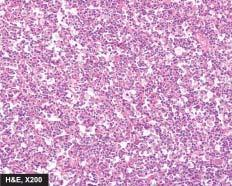what does the tumour show having high mitotic rate?
Answer the question using a single word or phrase. Uniform cells 